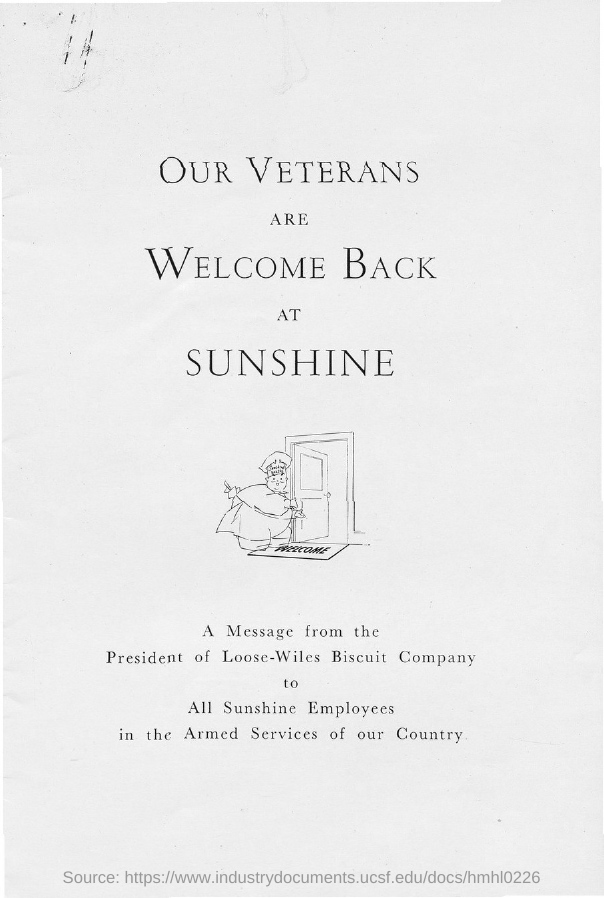List a handful of essential elements in this visual. The title of the document is 'Our veterans are welcome back at sunshine,' which clearly and unequivocally expresses the sentiment that our veterans are welcomed back at sunshine. 